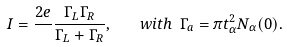Convert formula to latex. <formula><loc_0><loc_0><loc_500><loc_500>I = \frac { 2 e } { } \frac { \Gamma _ { L } \Gamma _ { R } } { \Gamma _ { L } + \Gamma _ { R } } , \quad w i t h \ \Gamma _ { a } = \pi t _ { \alpha } ^ { 2 } N _ { \alpha } ( 0 ) .</formula> 